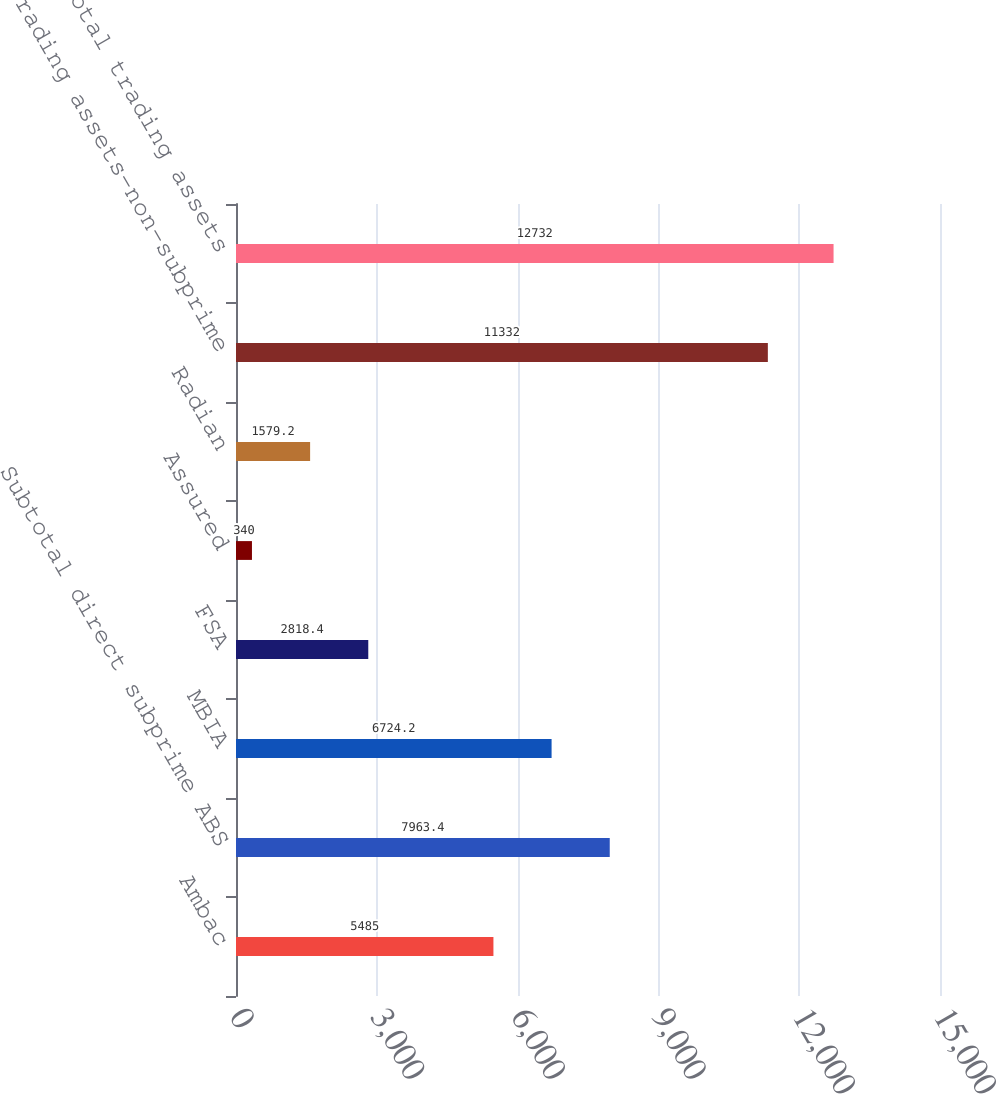Convert chart to OTSL. <chart><loc_0><loc_0><loc_500><loc_500><bar_chart><fcel>Ambac<fcel>Subtotal direct subprime ABS<fcel>MBIA<fcel>FSA<fcel>Assured<fcel>Radian<fcel>Trading assets-non-subprime<fcel>Subtotal trading assets<nl><fcel>5485<fcel>7963.4<fcel>6724.2<fcel>2818.4<fcel>340<fcel>1579.2<fcel>11332<fcel>12732<nl></chart> 